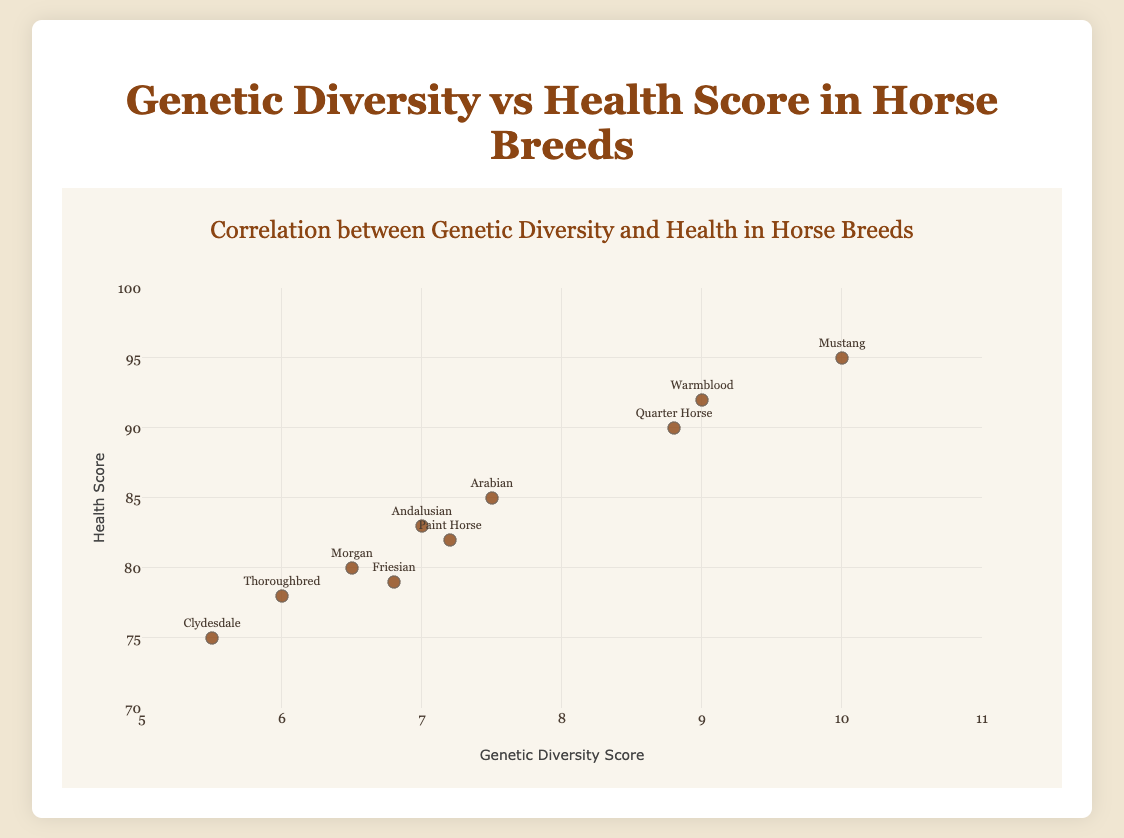How many horse breeds are displayed in the plot? Count the number of unique horse breed names in the plot. There are 10 names.
Answer: 10 What is the title of the plot? Observe the top part of the figure for the title text.
Answer: Correlation between Genetic Diversity and Health in Horse Breeds Which horse breed has the highest health score? Identify the horse breed with the highest y-axis value (Health Score). The Mustang breed has the highest health score of 95.
Answer: Mustang What is the range of genetic diversity scores shown on the x-axis? Look at the x-axis to determine the minimum and maximum genetic diversity scores. The range is from 5 to 11.
Answer: 5 to 11 Which horse breeds have a genetic diversity score greater than 8.0? Identify the breeds with x-axis (Genetic Diversity) values greater than 8.0. The breeds are Quarter Horse, Warmblood, and Mustang.
Answer: Quarter Horse, Warmblood, Mustang Is there a positive correlation between genetic diversity and health score? Observe the direction of the data points' distribution. Since higher genetic diversity scores (x-axis) correspond with higher health scores (y-axis), there is a positive correlation.
Answer: Yes What is the difference in health score between the horse with the highest genetic diversity and the horse with the lowest genetic diversity? Find the health scores of the horse with the highest genetic diversity (Mustang) and the lowest genetic diversity (Clydesdale). The difference is 95 - 75 = 20.
Answer: 20 Which horse breed has a higher health score: Friesian or Morgan? Compare the y-axis (Health Score) values of Friesian (79) and Morgan (80). Morgan has a higher health score.
Answer: Morgan What is the average health score of all the horse breeds? Sum all the health scores (85 + 78 + 90 + 82 + 80 + 92 + 83 + 75 + 79 + 95 = 839) and divide by the number of breeds (10). The average is 839 / 10 = 83.9.
Answer: 83.9 Which horse breeds have both genetic diversity scores and health scores above the average values? Calculate the average genetic diversity (sum = 76.3, average = 76.3 / 10 = 7.63) and compare each breed's scores to these averages. Only Quarter Horse and Mustang satisfy this condition.
Answer: Quarter Horse, Mustang 